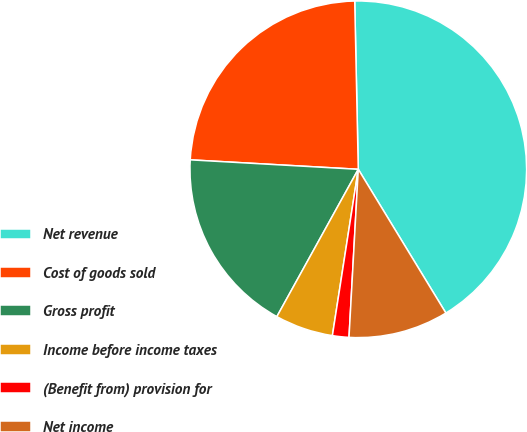Convert chart. <chart><loc_0><loc_0><loc_500><loc_500><pie_chart><fcel>Net revenue<fcel>Cost of goods sold<fcel>Gross profit<fcel>Income before income taxes<fcel>(Benefit from) provision for<fcel>Net income<nl><fcel>41.63%<fcel>23.77%<fcel>17.86%<fcel>5.58%<fcel>1.58%<fcel>9.59%<nl></chart> 